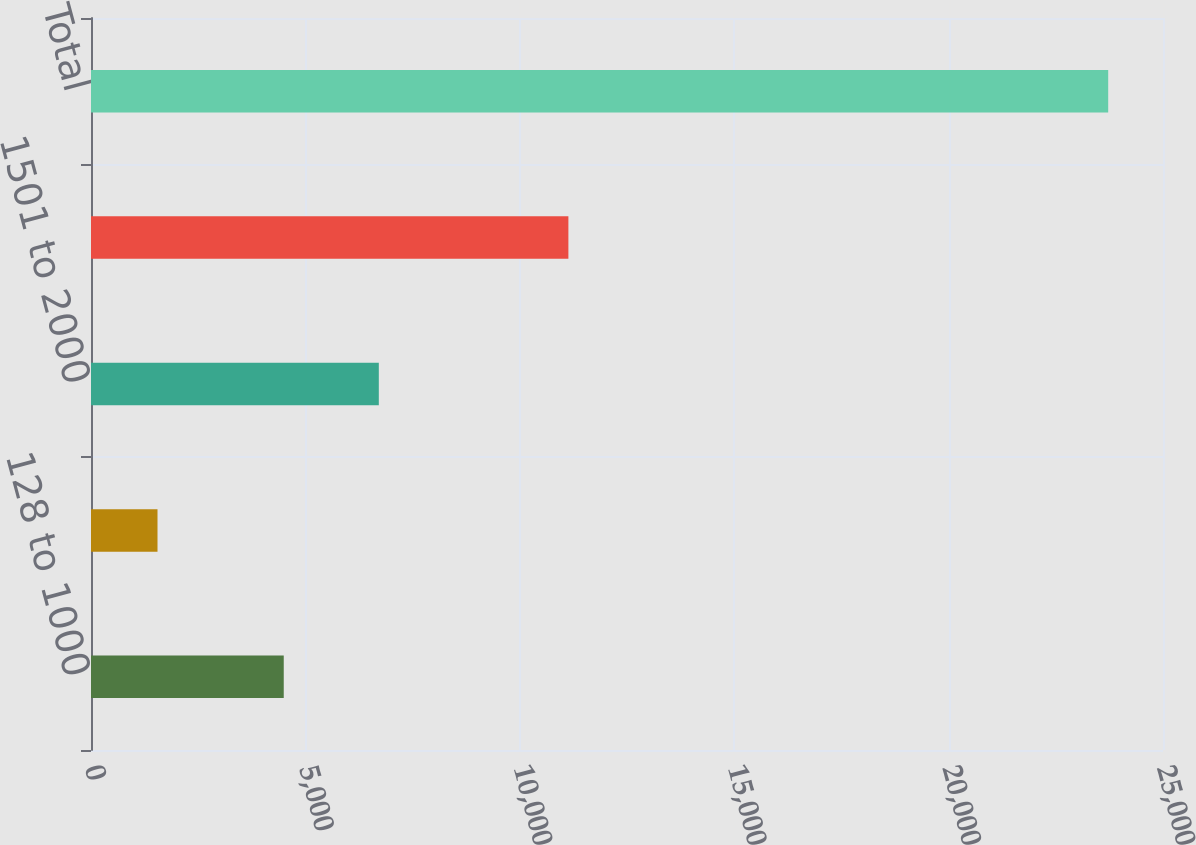Convert chart to OTSL. <chart><loc_0><loc_0><loc_500><loc_500><bar_chart><fcel>128 to 1000<fcel>1001 to 1500<fcel>1501 to 2000<fcel>2001 to 2501<fcel>Total<nl><fcel>4495<fcel>1551<fcel>6712.1<fcel>11133<fcel>23722<nl></chart> 